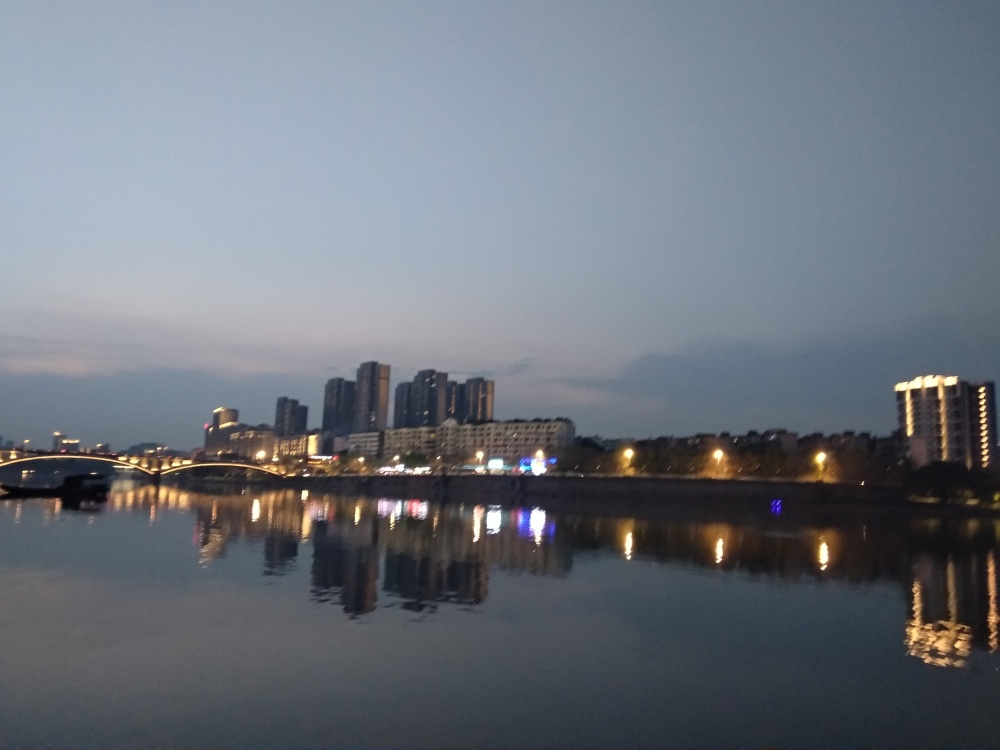Can you describe the atmosphere or mood of this location? The image conveys a calm and peaceful mood, with the city lights reflecting off the water surface. The blue hour glow casts a soothing ambiance over the urban skyline, suggesting a lull in activity where the day's hustle gives way to the evening's tranquility. 